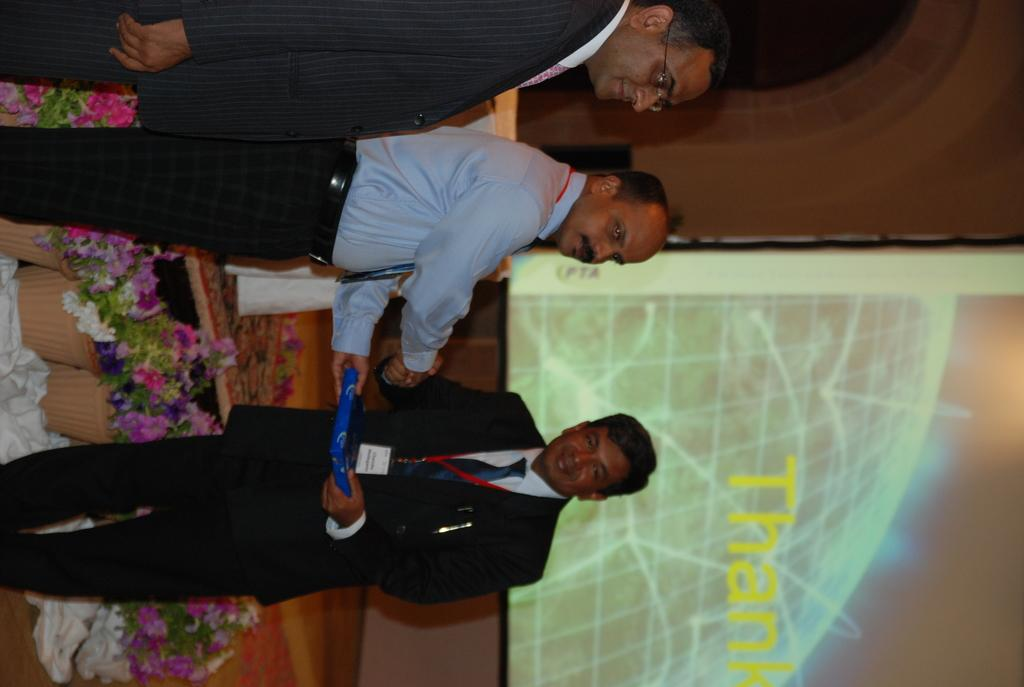What are the two men in the center of the image doing? The two men in the center of the image are shaking hands. Is there anyone else present in the image? Yes, there is a third man beside them. What can be seen in the background of the image? There are flower pots, a screen, a table, and a speaker in the background. How many keys are hanging from the beam in the image? There is no beam or keys present in the image. Are there any spiders crawling on the table in the background? There is no mention of spiders in the image, and the focus is on the objects and people present, not any insects or animals. 